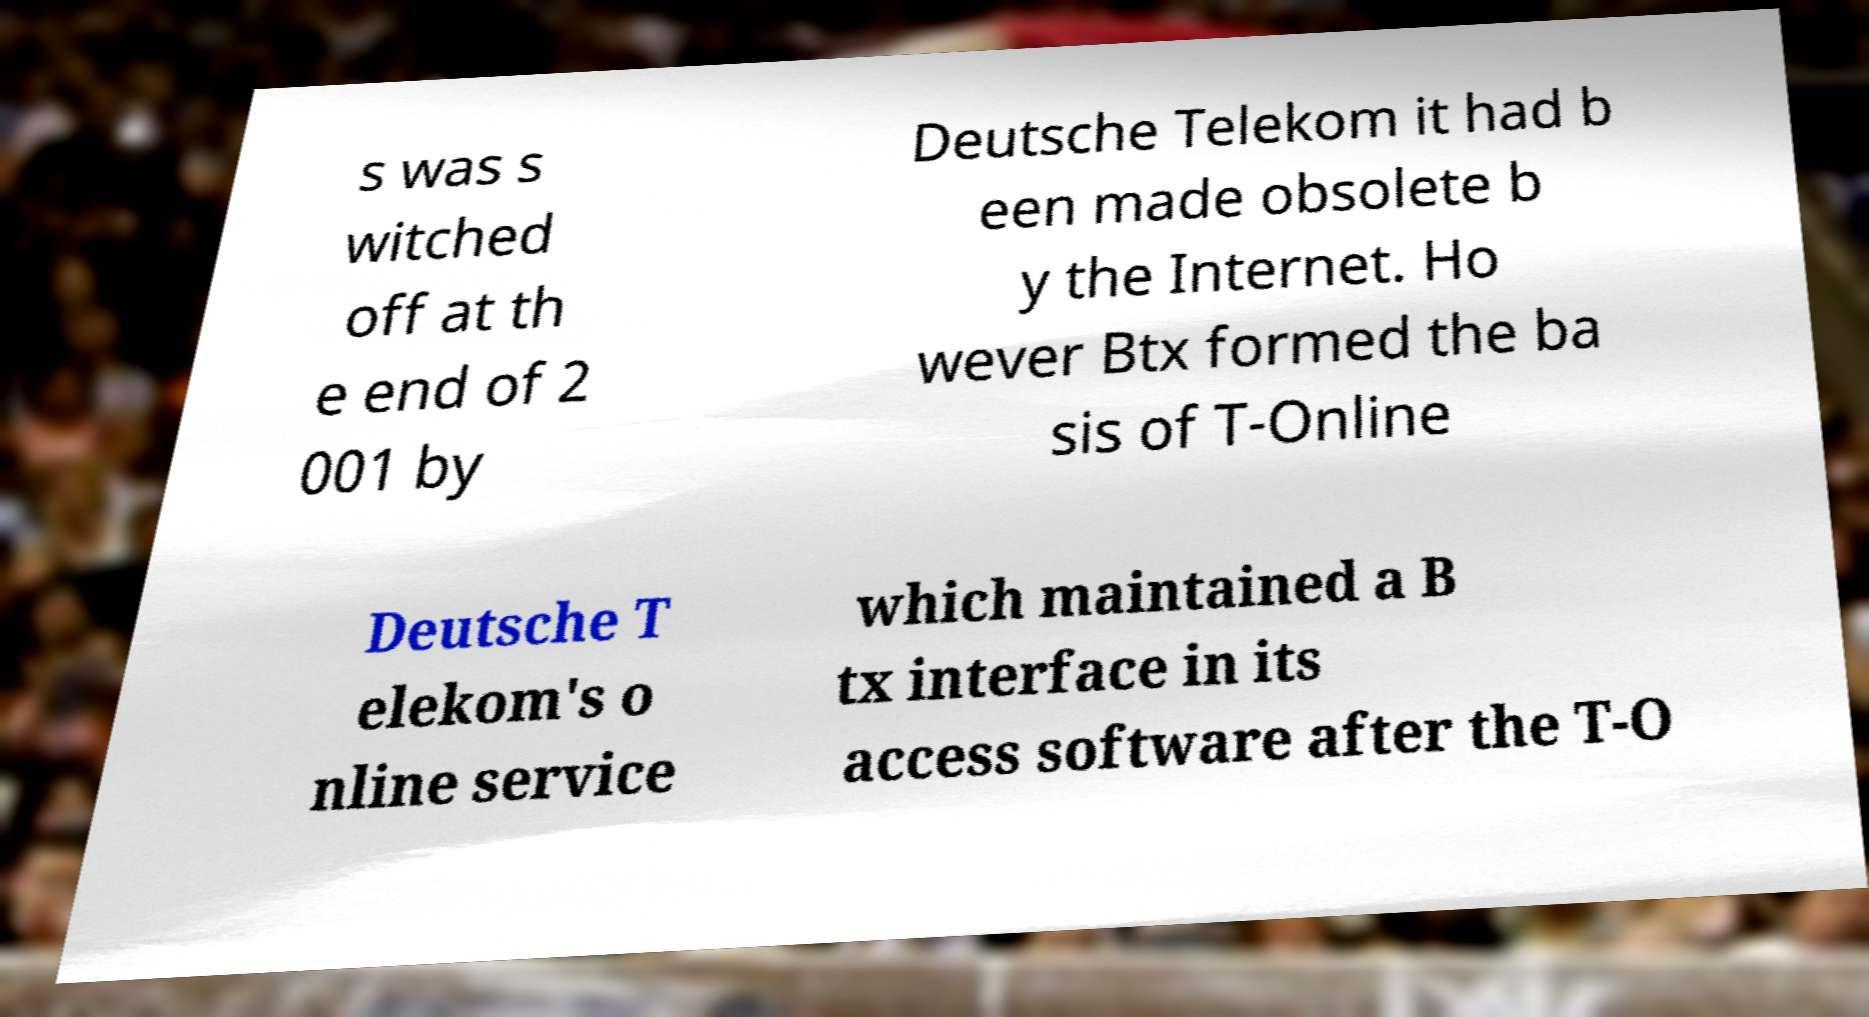Please identify and transcribe the text found in this image. s was s witched off at th e end of 2 001 by Deutsche Telekom it had b een made obsolete b y the Internet. Ho wever Btx formed the ba sis of T-Online Deutsche T elekom's o nline service which maintained a B tx interface in its access software after the T-O 